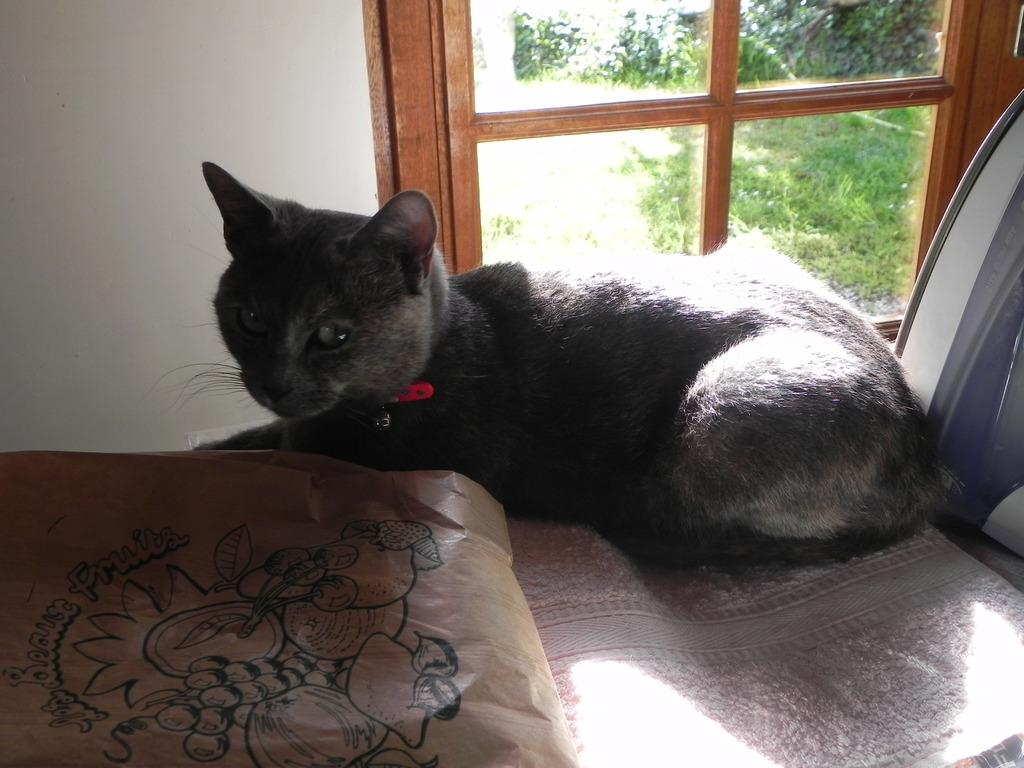What type of animal is in the image? There is a black cat in the image. What object is also visible in the image? There is a paper bag in the image. What can be seen through the window in the image? Trees are visible through the window. What is the ground made of in the image? Grass is present on the ground. What is the cat wearing in the image? The cat is wearing a red color belt around its neck. What type of border is visible on the paper bag in the image? There is no mention of a border on the paper bag in the image. 